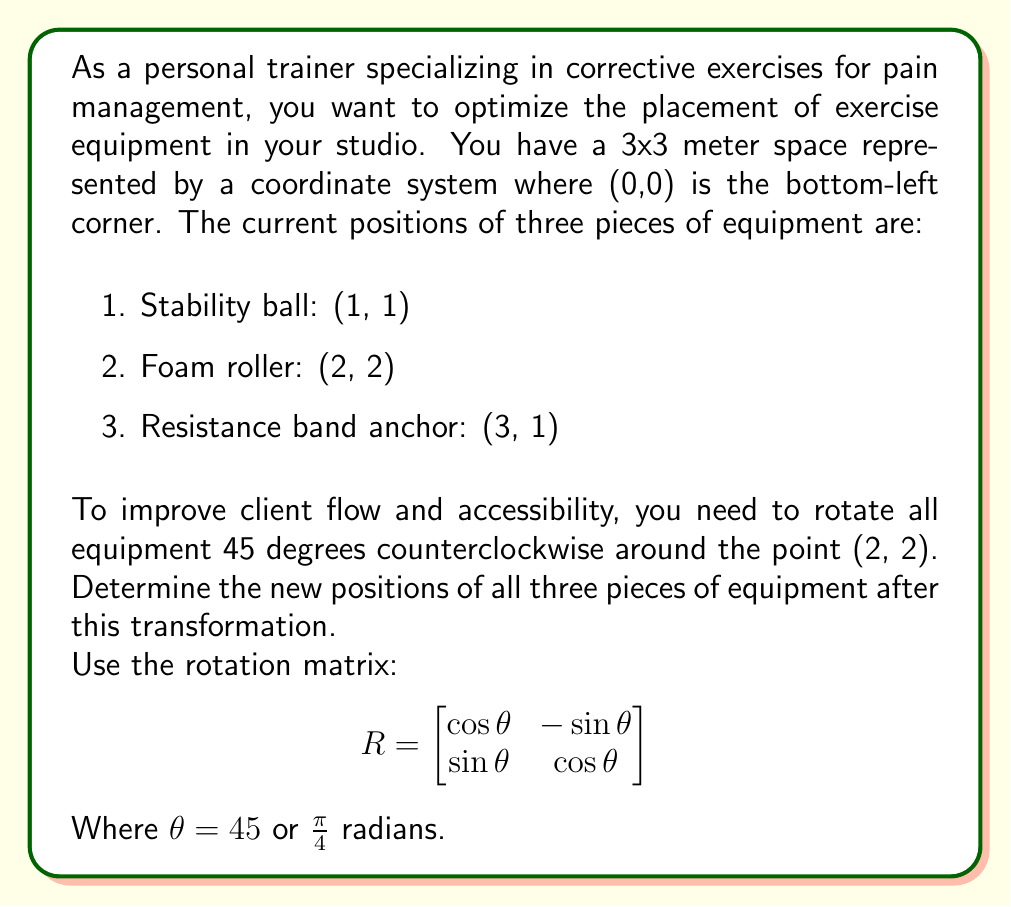Help me with this question. To solve this problem, we'll follow these steps:

1. Translate the coordinate system so that the rotation point (2, 2) becomes the origin.
2. Apply the rotation matrix to each translated point.
3. Translate the rotated points back to the original coordinate system.

Step 1: Translate points
Subtract (2, 2) from each point:
- Stability ball: (1, 1) - (2, 2) = (-1, -1)
- Foam roller: (2, 2) - (2, 2) = (0, 0)
- Resistance band anchor: (3, 1) - (2, 2) = (1, -1)

Step 2: Apply rotation matrix
For $\theta = 45°$, $\cos \theta = \sin \theta = \frac{\sqrt{2}}{2}$

Rotation matrix:
$$R = \begin{bmatrix} 
\frac{\sqrt{2}}{2} & -\frac{\sqrt{2}}{2} \\
\frac{\sqrt{2}}{2} & \frac{\sqrt{2}}{2}
\end{bmatrix}$$

For each point $(x, y)$, multiply by $R$:
$$(x', y') = R \cdot (x, y) = \begin{bmatrix} 
\frac{\sqrt{2}}{2} & -\frac{\sqrt{2}}{2} \\
\frac{\sqrt{2}}{2} & \frac{\sqrt{2}}{2}
\end{bmatrix} \cdot \begin{bmatrix} 
x \\ y
\end{bmatrix}$$

Stability ball: $(-1, -1)$
$$\begin{bmatrix} 
\frac{\sqrt{2}}{2} & -\frac{\sqrt{2}}{2} \\
\frac{\sqrt{2}}{2} & \frac{\sqrt{2}}{2}
\end{bmatrix} \cdot \begin{bmatrix} 
-1 \\ -1
\end{bmatrix} = \begin{bmatrix} 
0 \\ -\sqrt{2}
\end{bmatrix}$$

Foam roller: $(0, 0)$
$$\begin{bmatrix} 
\frac{\sqrt{2}}{2} & -\frac{\sqrt{2}}{2} \\
\frac{\sqrt{2}}{2} & \frac{\sqrt{2}}{2}
\end{bmatrix} \cdot \begin{bmatrix} 
0 \\ 0
\end{bmatrix} = \begin{bmatrix} 
0 \\ 0
\end{bmatrix}$$

Resistance band anchor: $(1, -1)$
$$\begin{bmatrix} 
\frac{\sqrt{2}}{2} & -\frac{\sqrt{2}}{2} \\
\frac{\sqrt{2}}{2} & \frac{\sqrt{2}}{2}
\end{bmatrix} \cdot \begin{bmatrix} 
1 \\ -1
\end{bmatrix} = \begin{bmatrix} 
\sqrt{2} \\ 0
\end{bmatrix}$$

Step 3: Translate back
Add (2, 2) to each rotated point:
- Stability ball: $(0, -\sqrt{2}) + (2, 2) = (2, 2-\sqrt{2})$
- Foam roller: $(0, 0) + (2, 2) = (2, 2)$
- Resistance band anchor: $(\sqrt{2}, 0) + (2, 2) = (2+\sqrt{2}, 2)$
Answer: The new positions of the equipment after rotation are:
1. Stability ball: $(2, 2-\sqrt{2}) \approx (2, 0.59)$
2. Foam roller: $(2, 2)$
3. Resistance band anchor: $(2+\sqrt{2}, 2) \approx (3.41, 2)$ 